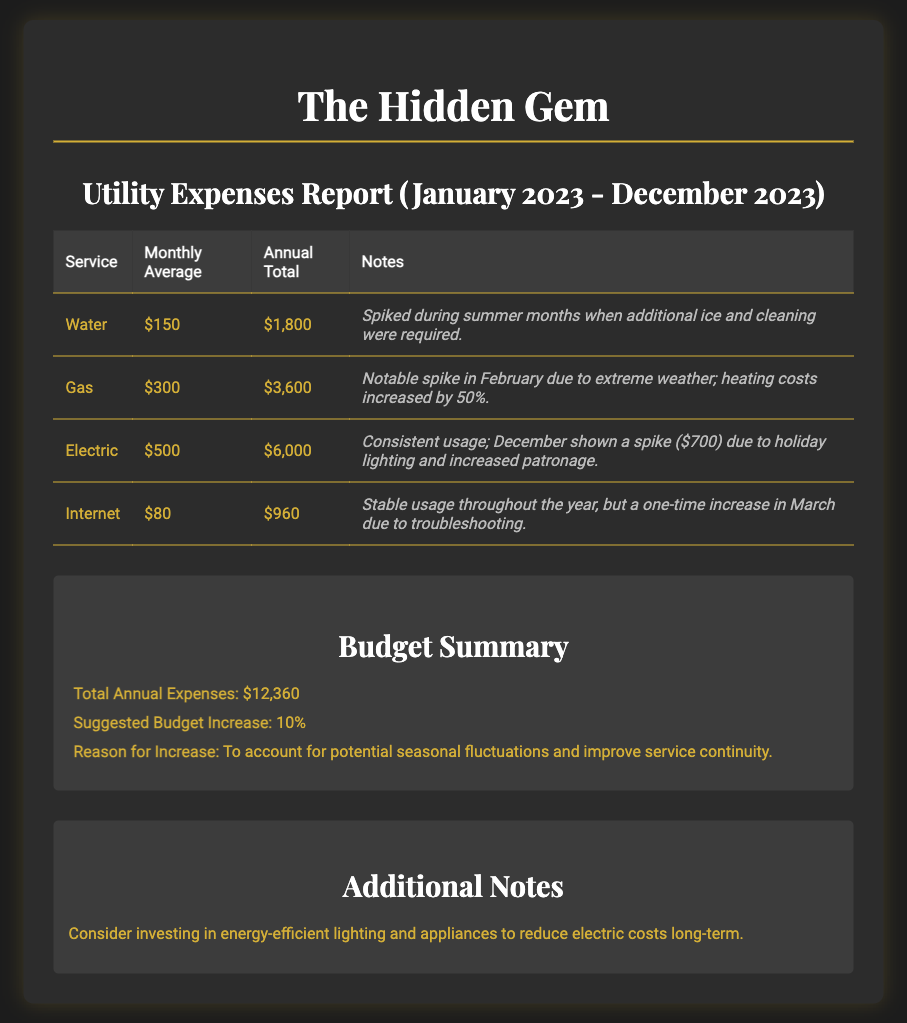What is the monthly average expense for Water? The monthly average expense for Water is listed in the report as $150.
Answer: $150 What is the annual total for Gas expenses? The annual total for Gas expenses is directly provided in the report, which states it is $3,600.
Answer: $3,600 What notable spike occurred in February? The report mentions a notable spike in February for Gas due to extreme weather, increasing costs by 50%.
Answer: Extreme weather What was the electric expense in December? The document indicates a spike in Electric expenses in December, which totaled $700.
Answer: $700 What is the suggested budget increase percentage? The suggested budget increase percentage is specified in the summary as 10%.
Answer: 10% What is the total annual expense reported? The total annual expenses according to the report is $12,360.
Answer: $12,360 What could help reduce electric costs long-term? The additional notes suggest investing in energy-efficient lighting and appliances to reduce electric costs.
Answer: Energy-efficient lighting What is the average monthly expense for Internet? The average monthly expense for Internet services is $80, as stated in the report.
Answer: $80 What was the cause for the spike in Internet expenses in March? The report notes that the spike in Internet expenses in March was due to troubleshooting.
Answer: Troubleshooting 